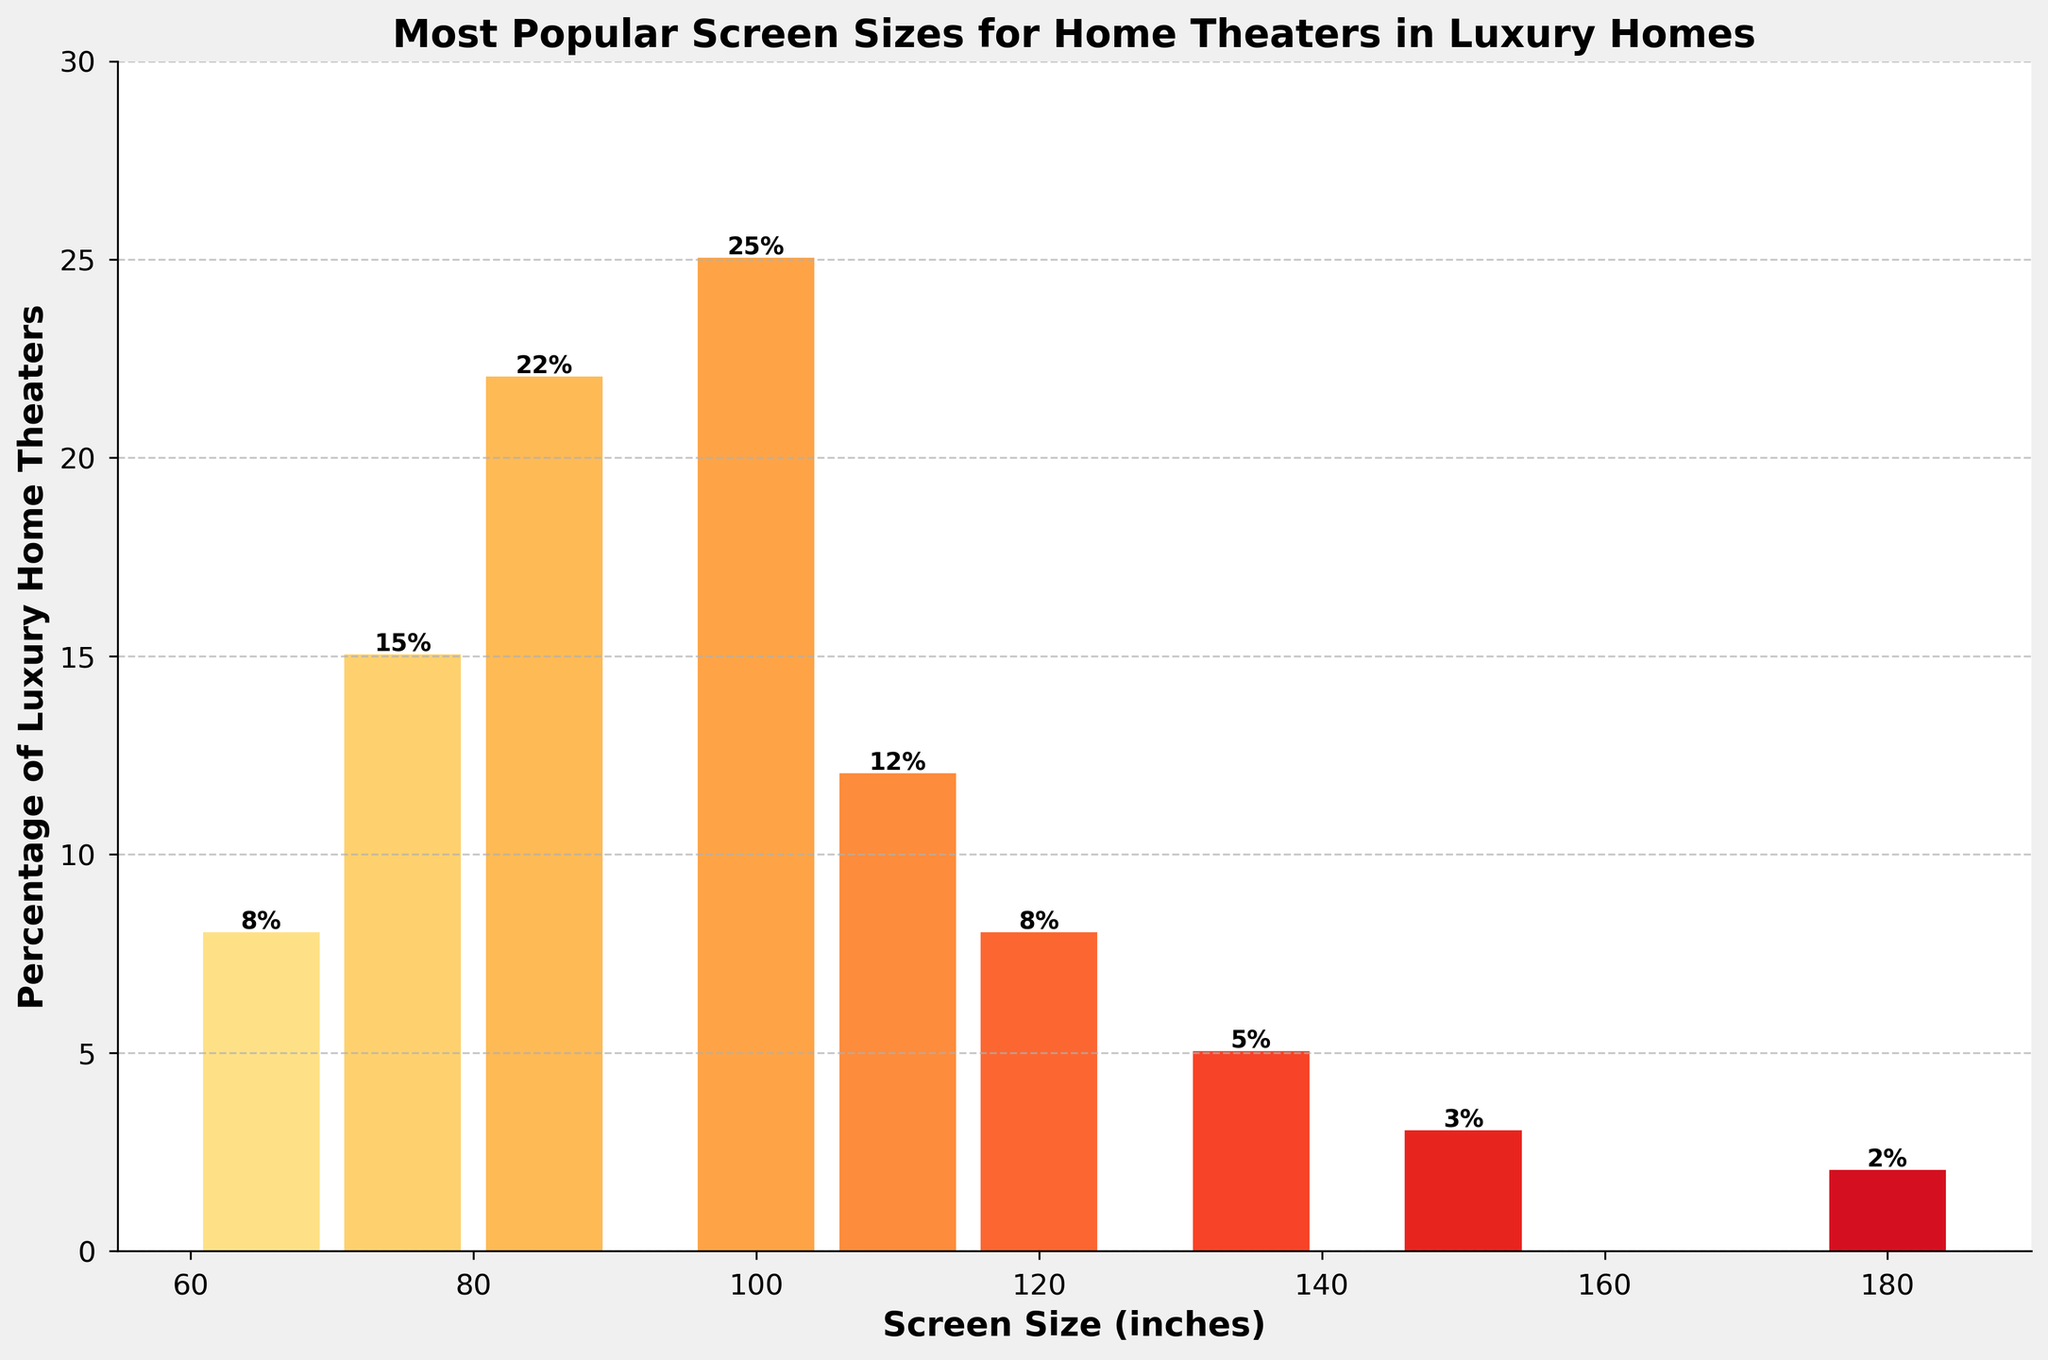What screen size has the highest percentage of luxury home theaters? The bar representing the 100-inch screen size has the highest height, which visually indicates that it has the highest percentage.
Answer: 100 inches How does the percentage of 85-inch screens compare to 65-inch screens? The bar for 85-inch screens is 22%, while the bar for 65-inch screens is 8%. Comparing the heights, the 85-inch screen percentage is greater.
Answer: 85-inch screens have a higher percentage than 65-inch screens What's the combined percentage of luxury home theaters using 100-inch and 110-inch screens? Adding the percentage of 100-inch screens (25%) to the percentage of 110-inch screens (12%) results in 25% + 12% = 37%.
Answer: 37% Which screen size shows a lower percentage: 135 inches or 150 inches? Comparing the heights of the bars for 135 inches (5%) and 150 inches (3%), the 150-inch screen has a lower percentage.
Answer: 150 inches What is the average percentage of luxury home theaters for screen sizes 75, 85, and 100 inches? Sum the percentages for the 75-inch (15%), 85-inch (22%), and 100-inch (25%) screens: 15 + 22 + 25 = 62. Divide by the number of screen sizes (3): 62 / 3 = 20.67%.
Answer: 20.67% What's the percentage difference between the most and least popular screen sizes? Subtract the percentage of the least popular screen size (180-inch at 2%) from the most popular screen size (100-inch at 25%): 25% - 2% = 23%.
Answer: 23% Which screen sizes are tied in percentage usage? The heights of the bars for 65 inches and 120 inches are both 8%, making them tied in percentage usage.
Answer: 65 inches and 120 inches Is the 95-inch screen size included in the data? By scanning the screen size labels on the x-axis, the 95-inch size is not listed, indicating it is not included in the data.
Answer: No 